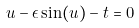<formula> <loc_0><loc_0><loc_500><loc_500>u - \epsilon \sin ( u ) - t = 0</formula> 